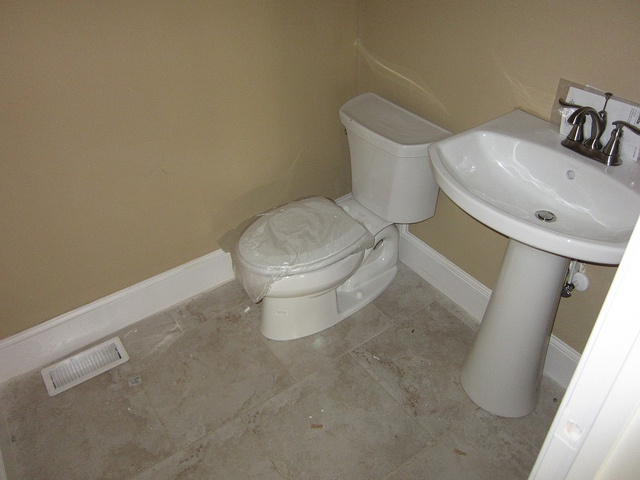Describe the objects in this image and their specific colors. I can see toilet in gray and darkgray tones and sink in gray, darkgray, lightgray, and black tones in this image. 